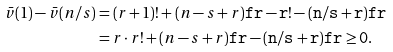<formula> <loc_0><loc_0><loc_500><loc_500>\bar { v } ( 1 ) - \bar { v } ( n / s ) & = ( r + 1 ) ! + ( n - s + r ) \tt f { r } - r ! - ( n / s + r ) \tt f { r } \\ & = r \cdot r ! + ( n - s + r ) \tt f { r } - ( n / s + r ) \tt f { r } \geq 0 .</formula> 